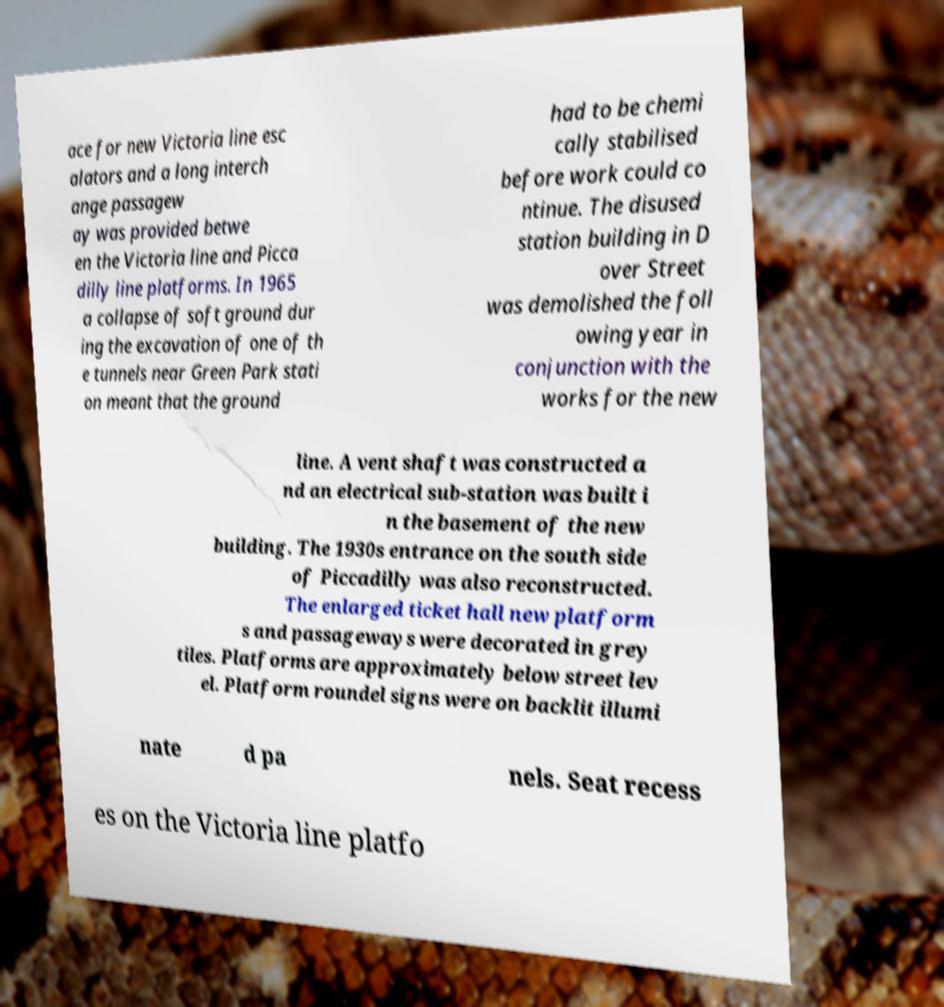Can you read and provide the text displayed in the image?This photo seems to have some interesting text. Can you extract and type it out for me? ace for new Victoria line esc alators and a long interch ange passagew ay was provided betwe en the Victoria line and Picca dilly line platforms. In 1965 a collapse of soft ground dur ing the excavation of one of th e tunnels near Green Park stati on meant that the ground had to be chemi cally stabilised before work could co ntinue. The disused station building in D over Street was demolished the foll owing year in conjunction with the works for the new line. A vent shaft was constructed a nd an electrical sub-station was built i n the basement of the new building. The 1930s entrance on the south side of Piccadilly was also reconstructed. The enlarged ticket hall new platform s and passageways were decorated in grey tiles. Platforms are approximately below street lev el. Platform roundel signs were on backlit illumi nate d pa nels. Seat recess es on the Victoria line platfo 